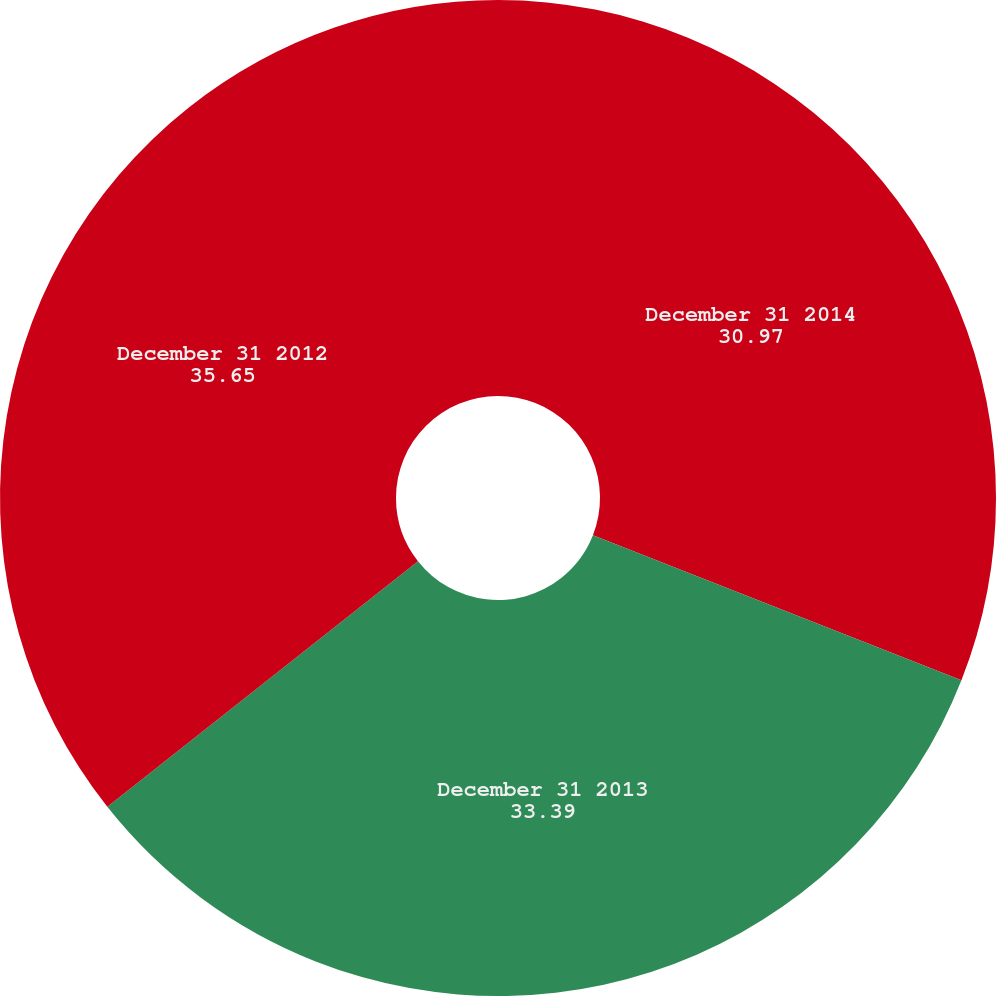Convert chart. <chart><loc_0><loc_0><loc_500><loc_500><pie_chart><fcel>December 31 2014<fcel>December 31 2013<fcel>December 31 2012<nl><fcel>30.97%<fcel>33.39%<fcel>35.65%<nl></chart> 